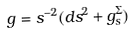Convert formula to latex. <formula><loc_0><loc_0><loc_500><loc_500>\ g = s ^ { - 2 } ( d s ^ { 2 } + g ^ { \Sigma } _ { s } )</formula> 